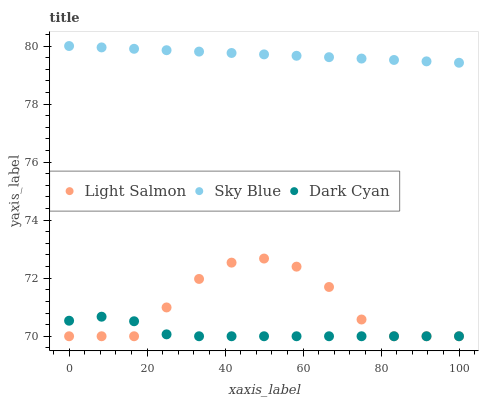Does Dark Cyan have the minimum area under the curve?
Answer yes or no. Yes. Does Sky Blue have the maximum area under the curve?
Answer yes or no. Yes. Does Light Salmon have the minimum area under the curve?
Answer yes or no. No. Does Light Salmon have the maximum area under the curve?
Answer yes or no. No. Is Sky Blue the smoothest?
Answer yes or no. Yes. Is Light Salmon the roughest?
Answer yes or no. Yes. Is Light Salmon the smoothest?
Answer yes or no. No. Is Sky Blue the roughest?
Answer yes or no. No. Does Dark Cyan have the lowest value?
Answer yes or no. Yes. Does Sky Blue have the lowest value?
Answer yes or no. No. Does Sky Blue have the highest value?
Answer yes or no. Yes. Does Light Salmon have the highest value?
Answer yes or no. No. Is Dark Cyan less than Sky Blue?
Answer yes or no. Yes. Is Sky Blue greater than Light Salmon?
Answer yes or no. Yes. Does Dark Cyan intersect Light Salmon?
Answer yes or no. Yes. Is Dark Cyan less than Light Salmon?
Answer yes or no. No. Is Dark Cyan greater than Light Salmon?
Answer yes or no. No. Does Dark Cyan intersect Sky Blue?
Answer yes or no. No. 